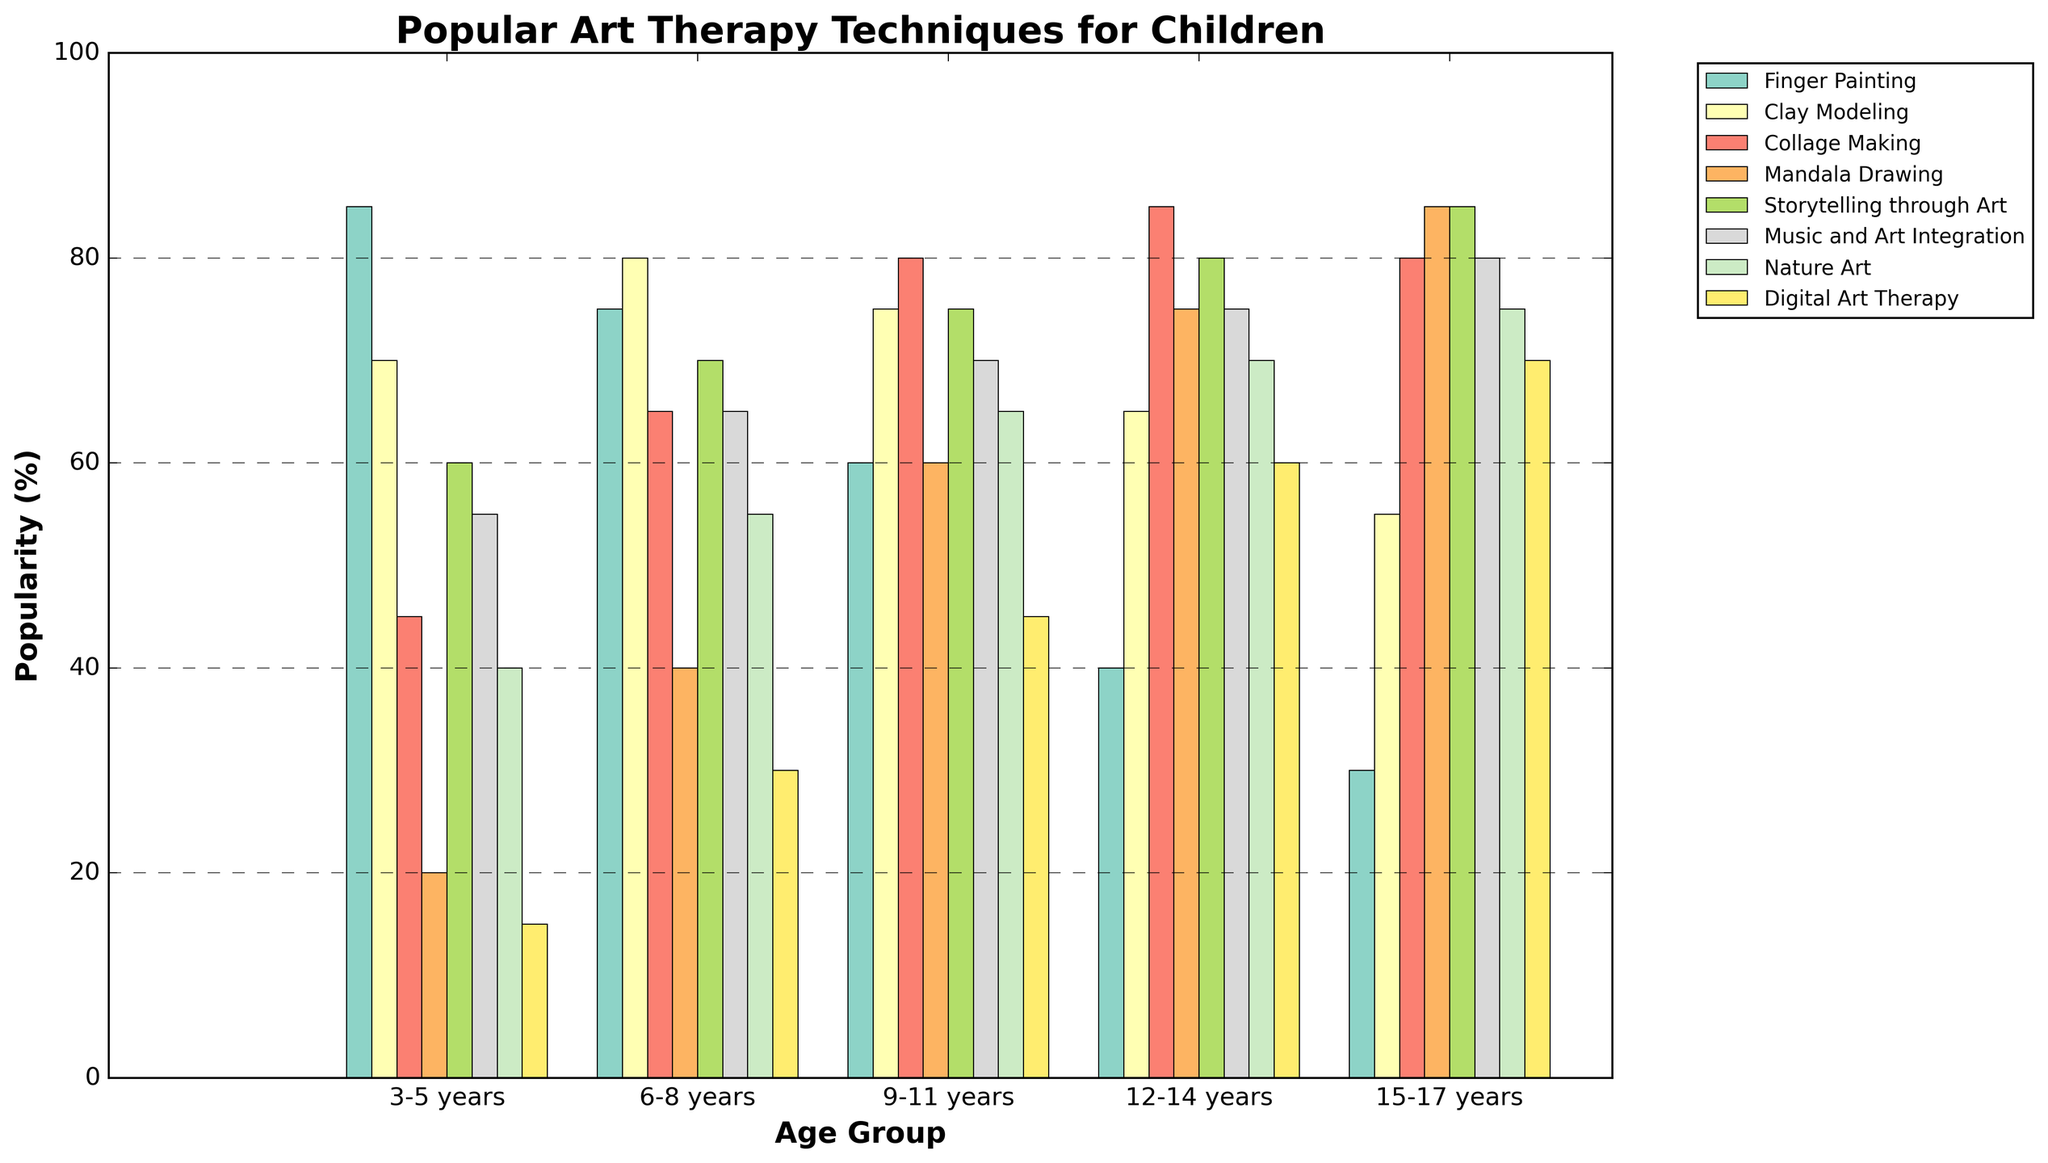What's the most popular art therapy technique for the 6-8 years age group? Look at the bar heights for the 6-8 years age group and find the highest one, which corresponds to 'Clay Modeling'.
Answer: Clay Modeling How does the popularity of Finger Painting change as children get older? Observe the bars for Finger Painting across all age groups. The heights of the bars decrease as the age groups progress from 3-5 years to 15-17 years.
Answer: Decreases Which age group shows the highest popularity for Digital Art Therapy, and what is the percentage? Look for the highest bar in the Digital Art Therapy category and identify the corresponding age group and height. The age group 15-17 years has the highest percentage at 70%.
Answer: 15-17 years, 70% Which two techniques have equal popularity for the age group 9-11 years? Compare the bar heights for the 9-11 years age group. 'Finger Painting' and 'Mandala Drawing' both stand at the same height of 60%.
Answer: Finger Painting and Mandala Drawing What is the total popularity of Storytelling through Art and Nature Art for the age group 12-14 years? Add the values for Storytelling through Art (80) and Nature Art (70) for the 12-14 years age group. 80 + 70 = 150.
Answer: 150 Which art therapy technique shows a steady increase in popularity as children get older? Compare the trends of all techniques across age groups. 'Digital Art Therapy' shows a steady increase in popularity from 15% (3-5 years) to 70% (15-17 years).
Answer: Digital Art Therapy What technique becomes more popular than Collage Making when children transition from ages 6-8 to 9-11? Compare the bar heights for 'Collage Making' and other techniques when transitioning from 6-8 years to 9-11 years. 'Mandala Drawing' (40 to 60) becomes more popular than 'Collage Making' (65 to 80).
Answer: Mandala Drawing What's the sum of the popularities of Mandala Drawing for all age groups? Add the value for Mandala Drawing across all age groups: 20 + 40 + 60 + 75 + 85 = 280.
Answer: 280 Which age group has the lowest popularity for Music and Art Integration? Look at the bars corresponding to 'Music and Art Integration' and identify the shortest one. The 3-5 years age group has the lowest at 55%.
Answer: 3-5 years What is the difference in popularity of Clay Modeling between the 3-5 years and 15-17 years age groups? Subtract the value of Clay Modeling for 15-17 years (55) from that of 3-5 years (70). 70 - 55 = 15.
Answer: 15 